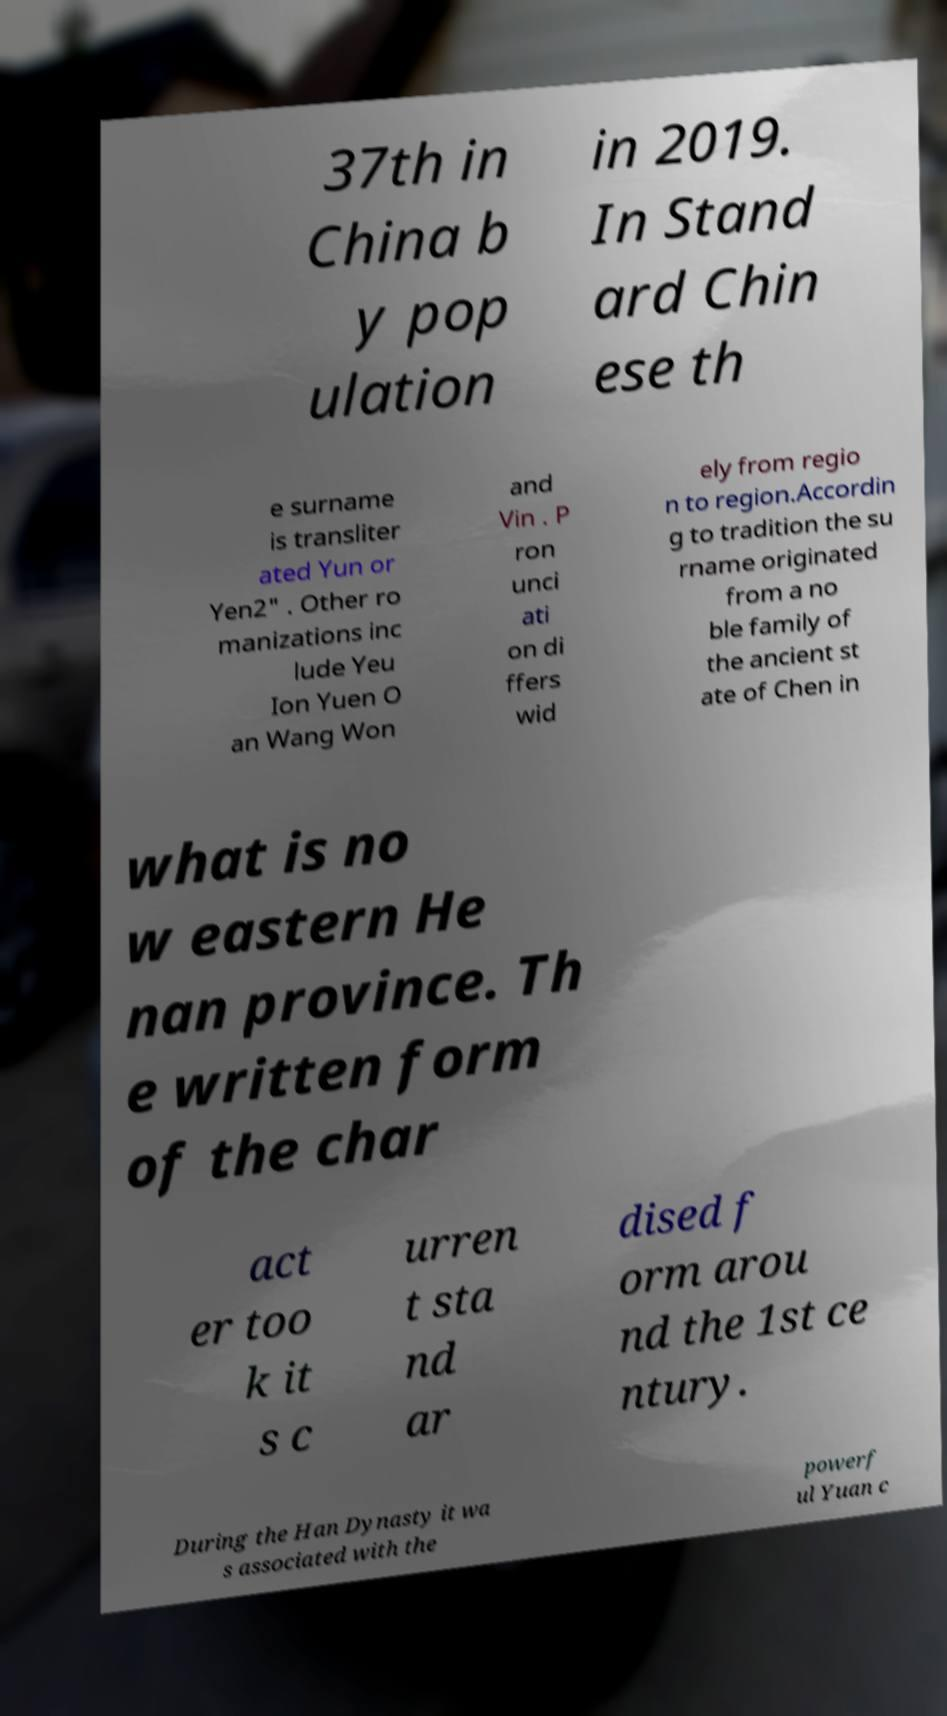What messages or text are displayed in this image? I need them in a readable, typed format. 37th in China b y pop ulation in 2019. In Stand ard Chin ese th e surname is transliter ated Yun or Yen2" . Other ro manizations inc lude Yeu Ion Yuen O an Wang Won and Vin . P ron unci ati on di ffers wid ely from regio n to region.Accordin g to tradition the su rname originated from a no ble family of the ancient st ate of Chen in what is no w eastern He nan province. Th e written form of the char act er too k it s c urren t sta nd ar dised f orm arou nd the 1st ce ntury. During the Han Dynasty it wa s associated with the powerf ul Yuan c 